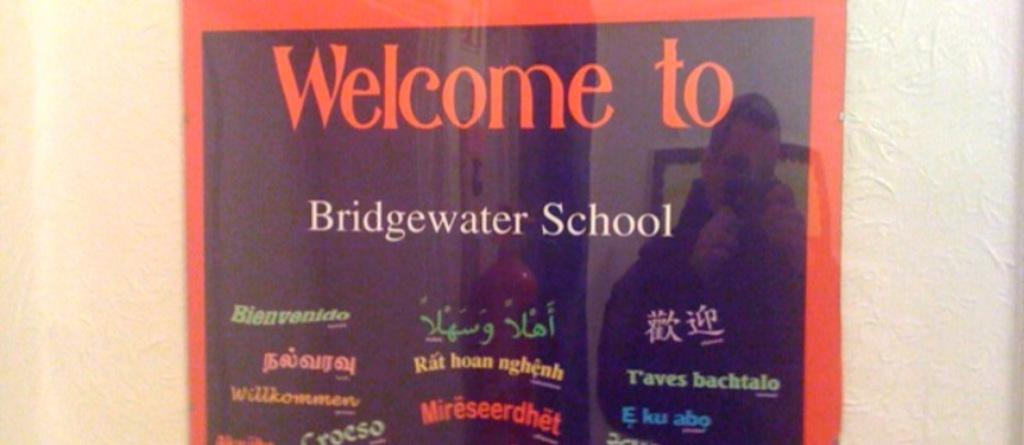<image>
Share a concise interpretation of the image provided. A sign welcomes visitors to Bridgewater School in various languages. 